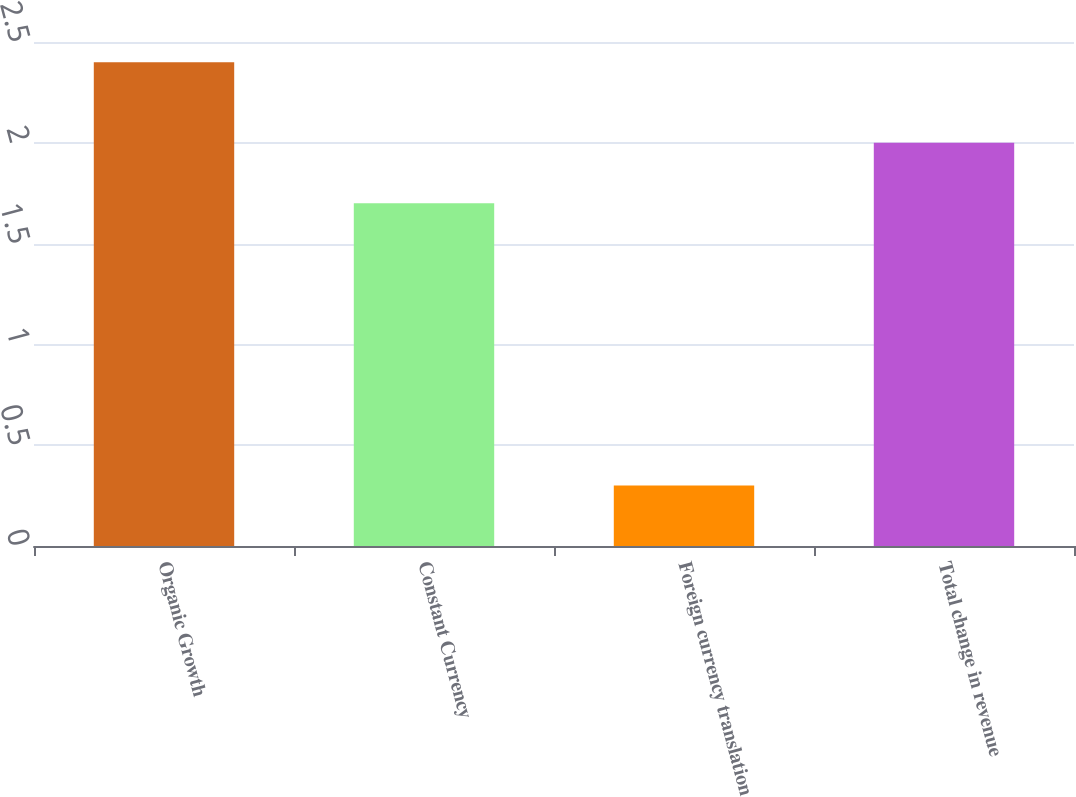Convert chart to OTSL. <chart><loc_0><loc_0><loc_500><loc_500><bar_chart><fcel>Organic Growth<fcel>Constant Currency<fcel>Foreign currency translation<fcel>Total change in revenue<nl><fcel>2.4<fcel>1.7<fcel>0.3<fcel>2<nl></chart> 